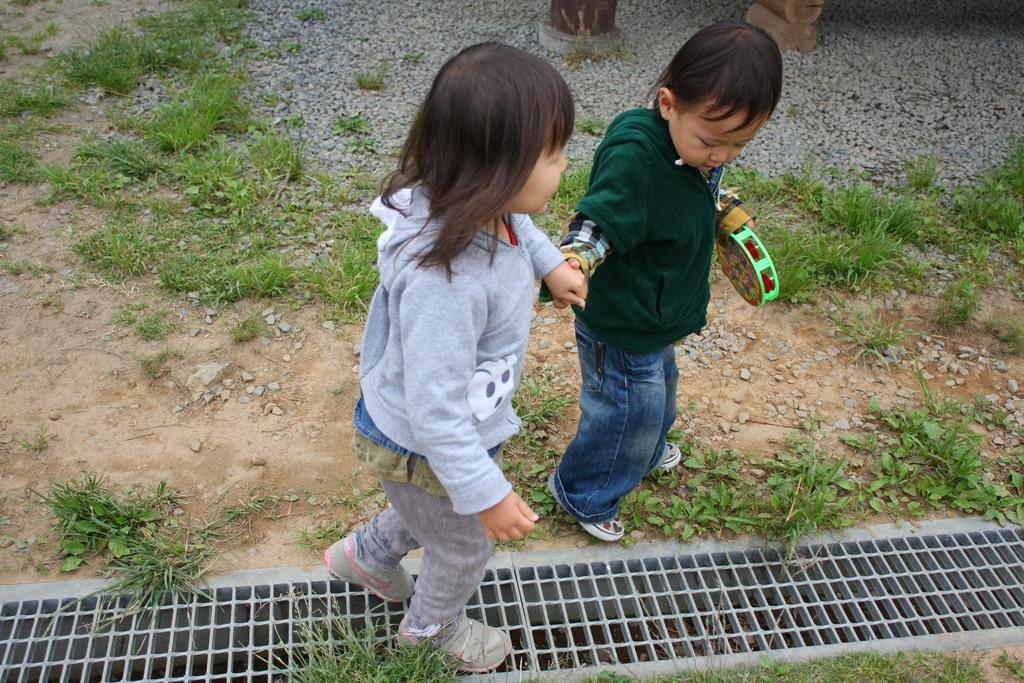How many people are in the image? There are two people in the image, a boy and a girl. What are the boy and girl doing in the image? The boy is holding the girl's hand and holding a toy in his other hand. What is the ground made of in the image? The ground is made of grass and stones in the image. What type of throat medicine is the boy taking in the image? There is no throat medicine or any indication of a throat issue in the image. 